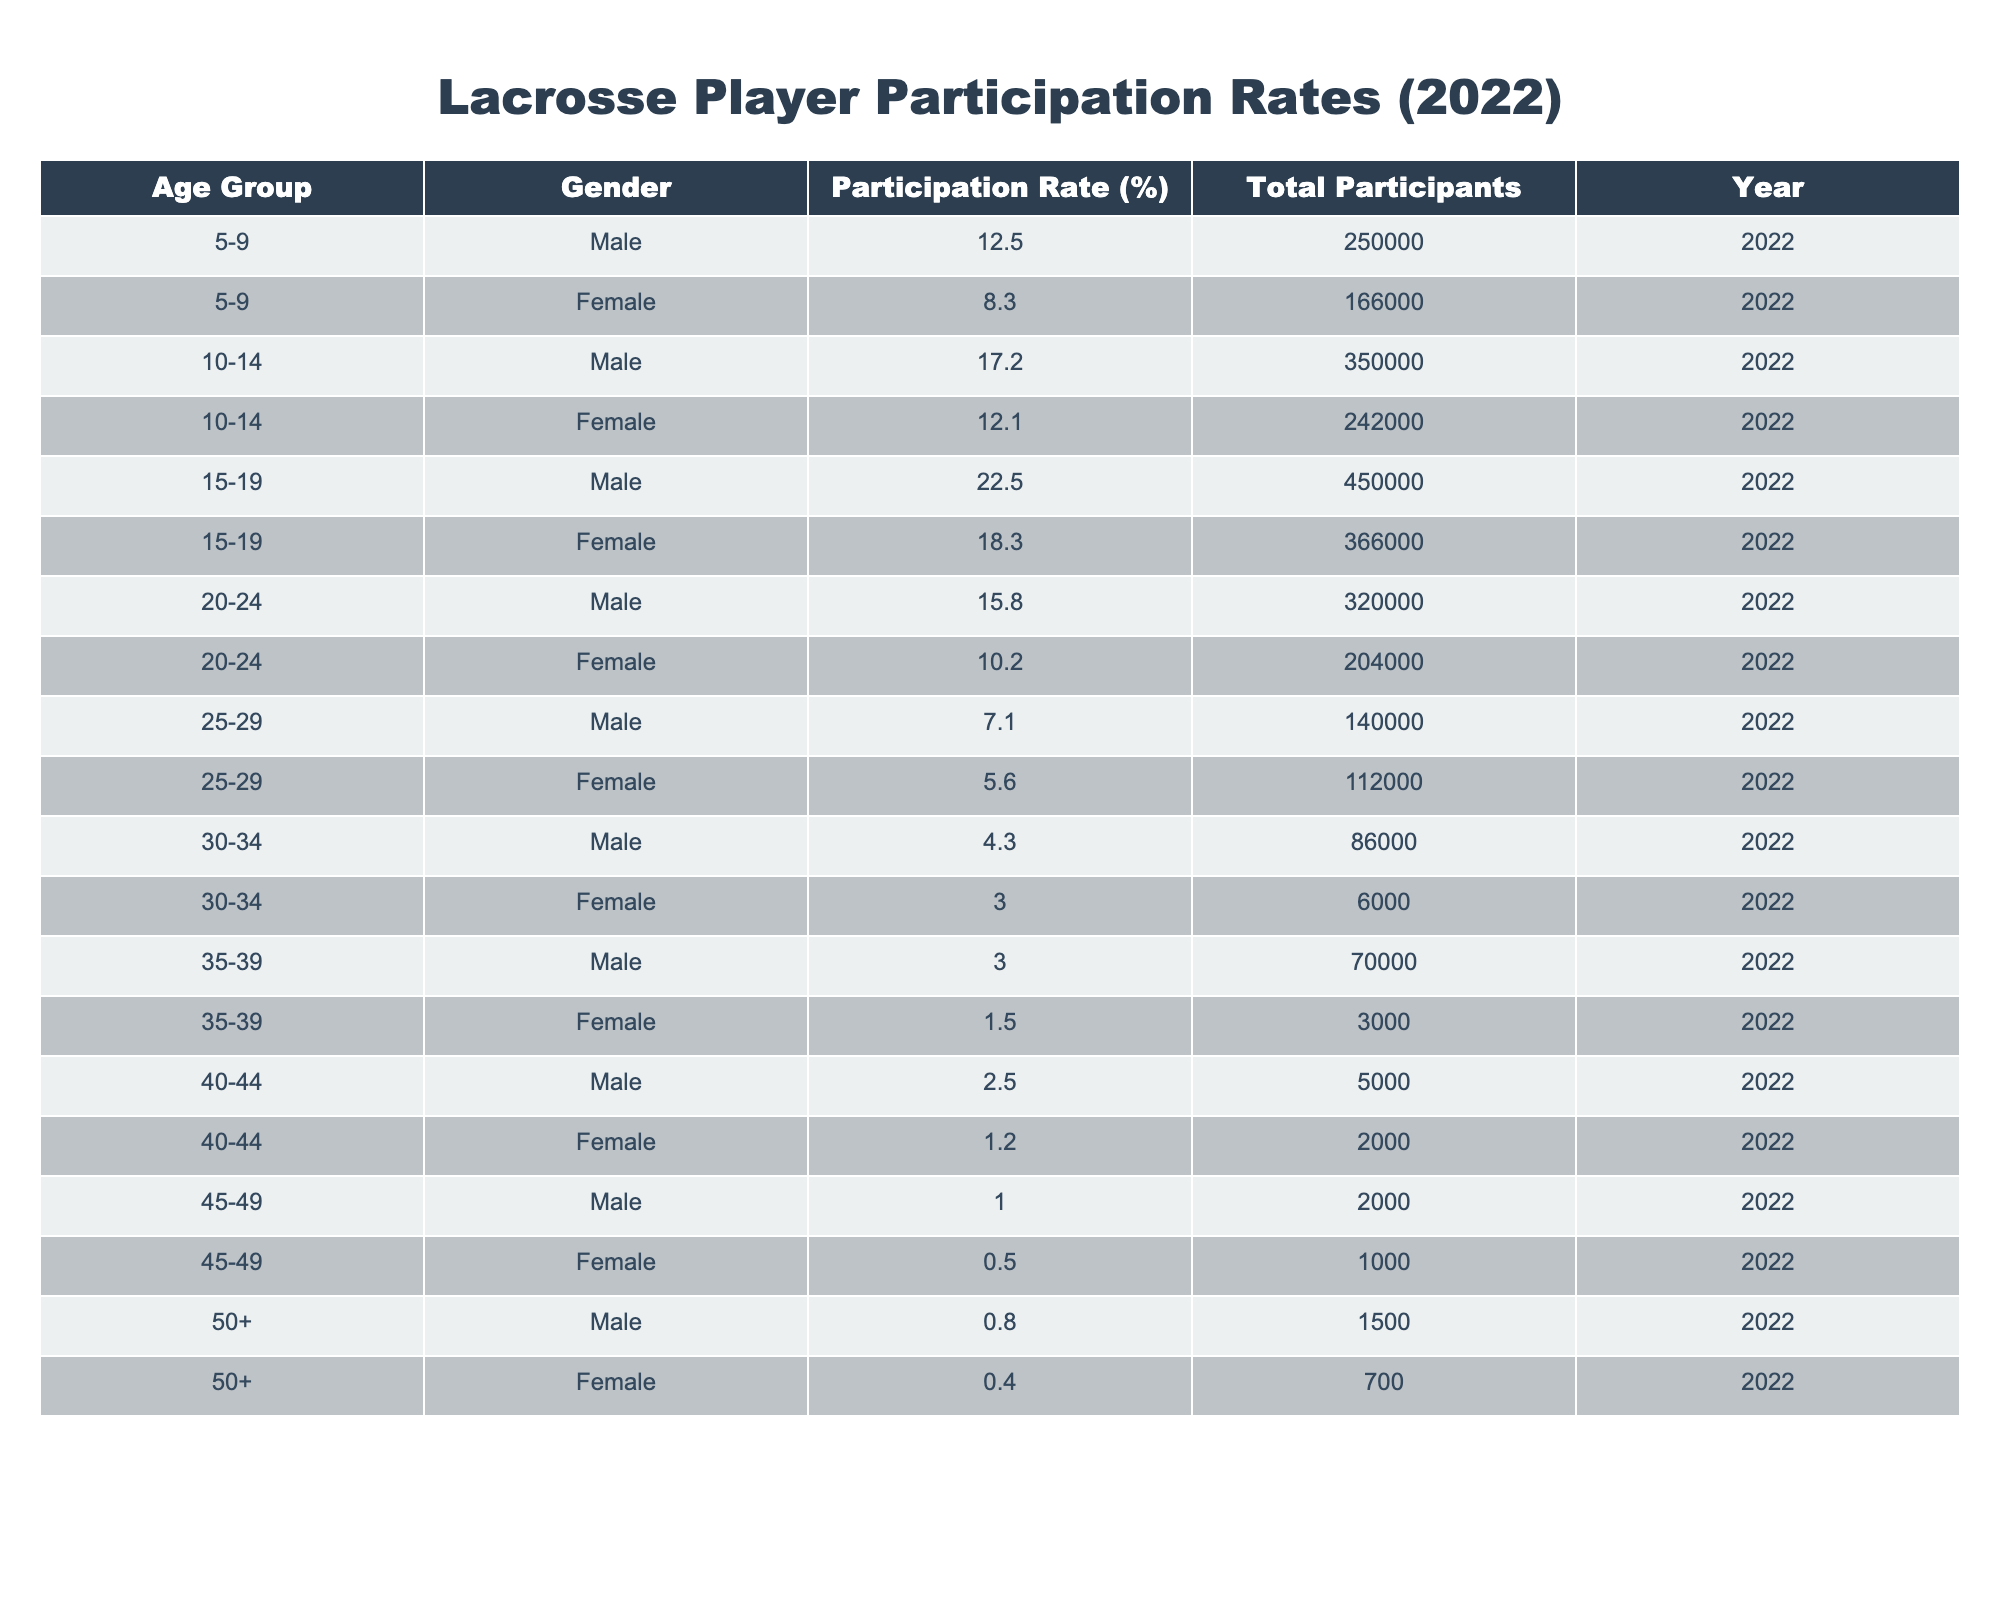What is the participation rate for males in the 15-19 age group? Looking at the table, the participation rate for males in the 15-19 age group is listed directly. It states 22.5%.
Answer: 22.5% What is the total number of female participants aged 10-14? The table shows that there are 242,000 female participants in the 10-14 age group, which is stated explicitly in the Total Participants column.
Answer: 242000 Which age group has the highest participation rate among females? By examining the Participation Rate for females, the 15-19 age group has the highest rate at 18.3%.
Answer: 15-19 What is the difference in participation rates between males and females in the 20-24 age group? The participation rate for males in the 20-24 age group is 15.8%, and for females, it is 10.2%. Calculating the difference: 15.8% - 10.2% = 5.6%.
Answer: 5.6% Are there any age groups where males have a higher participation rate compared to females? Yes, the data indicates that in all age groups provided (5-9, 10-14, 15-19, 20-24), males have a higher participation rate than females.
Answer: Yes What is the average participation rate for males across all age groups? To find the average, we sum the participation rates for males: 12.5% + 17.2% + 22.5% + 15.8% + 7.1% + 4.3% + 3.0% + 2.5% + 1.0% + 0.8% = 83.7%. Dividing by the number of age groups (10) gives an average of 8.37%.
Answer: 8.37% What age group has the lowest total number of participants for females? By comparing the Total Participants for females, the age group 30-34 has the lowest total at 6,000.
Answer: 30-34 What is the total number of male participants from ages 25 to 29? The table shows that there are 140,000 male participants in the 25-29 age group explicitly.
Answer: 140000 Was the female participation rate higher than 10% for any age group? Checking the Participation Rate column, the rates for ages 5-9 (8.3%), 10-14 (12.1%), 15-19 (18.3%), and 20-24 (10.2%) show that females had participation rates above 10% only in the 10-14, 15-19, and 20-24 age groups.
Answer: Yes What is the combined total number of participants for males and females in the 15-19 age group? In the 15-19 age group, males have 450,000 participants and females have 366,000 participants. Combining these gives 450,000 + 366,000 = 816,000.
Answer: 816000 